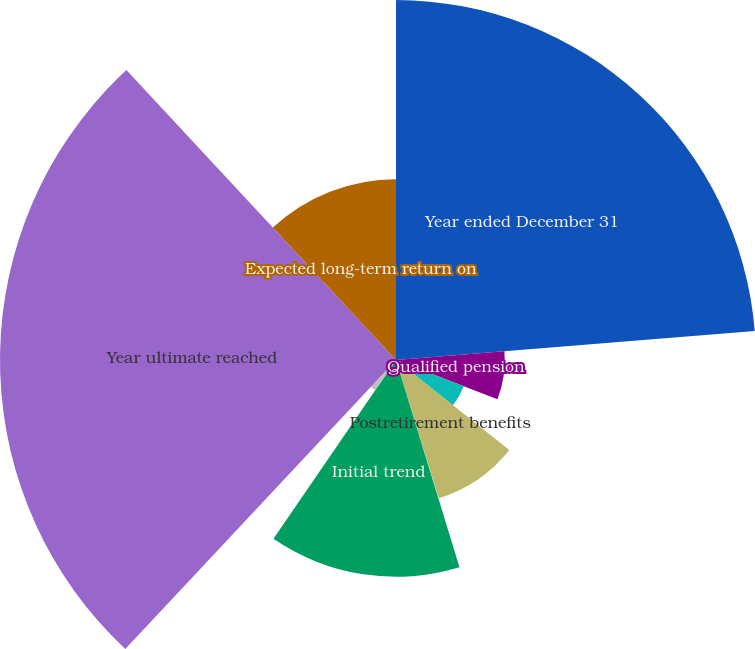<chart> <loc_0><loc_0><loc_500><loc_500><pie_chart><fcel>Year ended December 31<fcel>Qualified pension<fcel>Nonqualified pension<fcel>Postretirement benefits<fcel>Rate of compensation increase<fcel>Initial trend<fcel>Ultimate trend<fcel>Year ultimate reached<fcel>Expected long-term return on<nl><fcel>23.72%<fcel>7.17%<fcel>4.79%<fcel>9.54%<fcel>0.05%<fcel>14.29%<fcel>2.42%<fcel>26.1%<fcel>11.92%<nl></chart> 